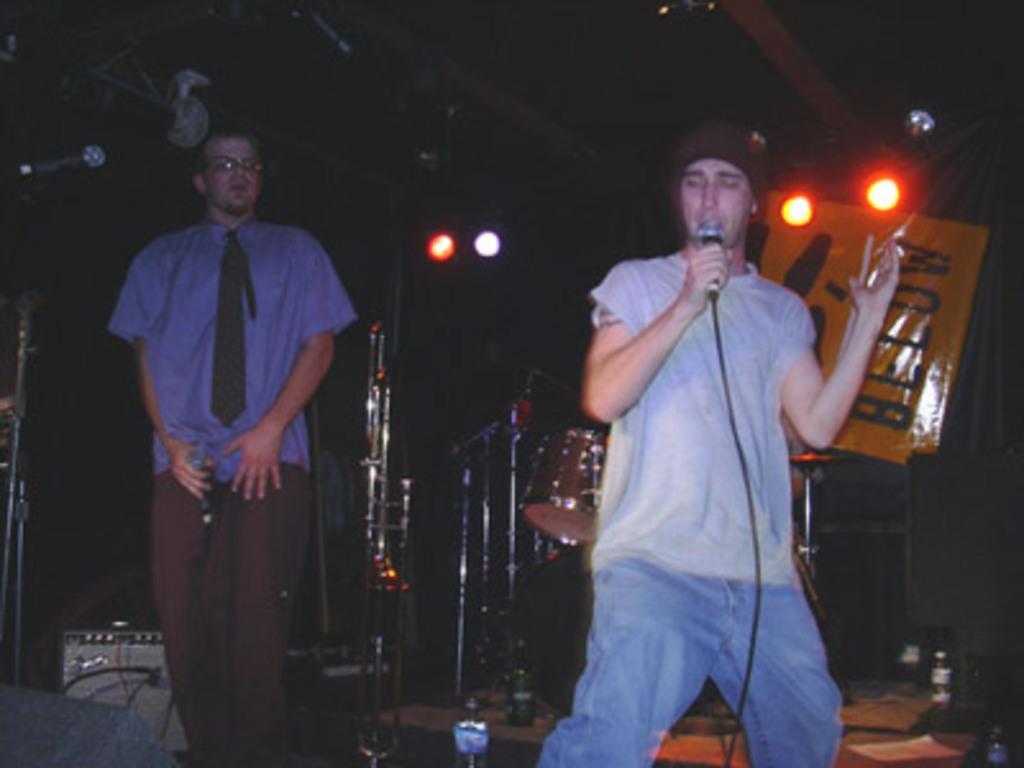Describe this image in one or two sentences. In this image I can see two men are standing and I can see both of them are holding mics. I can see one of them is wearing shirt and another one is wearing t shirt. I can also see he is wearing specs. In the background I can see drum set, few lights, a yellow colour board and on it I can see something is written. I can also see this image is little bit in dark from background. 